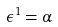Convert formula to latex. <formula><loc_0><loc_0><loc_500><loc_500>\epsilon ^ { 1 } = \alpha</formula> 